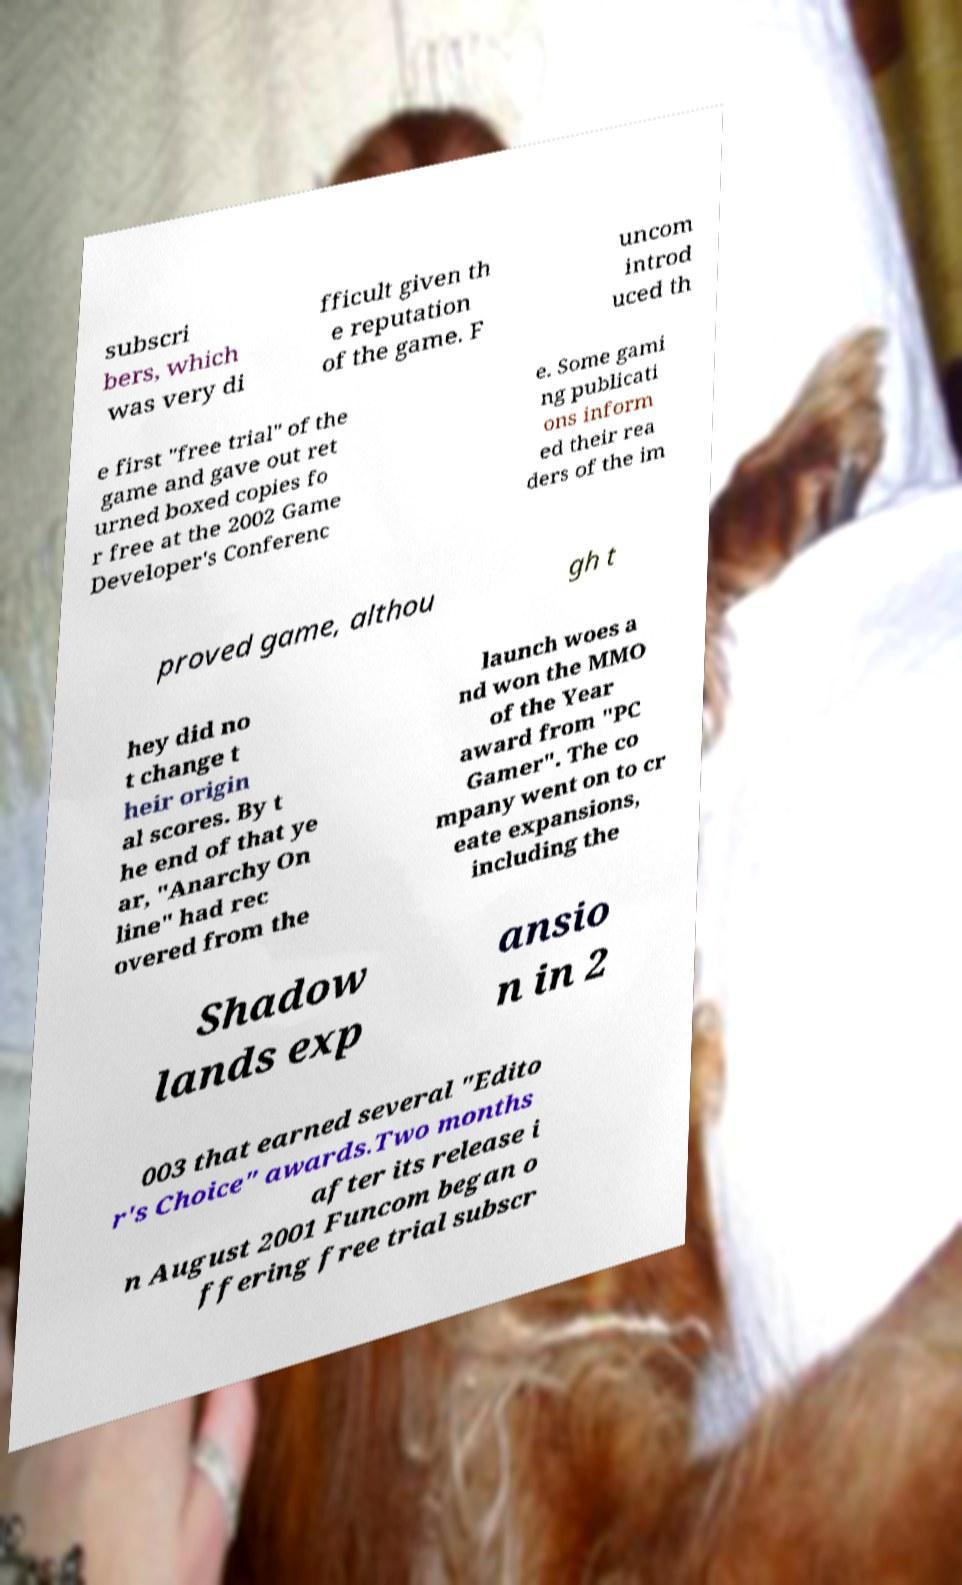What messages or text are displayed in this image? I need them in a readable, typed format. subscri bers, which was very di fficult given th e reputation of the game. F uncom introd uced th e first "free trial" of the game and gave out ret urned boxed copies fo r free at the 2002 Game Developer's Conferenc e. Some gami ng publicati ons inform ed their rea ders of the im proved game, althou gh t hey did no t change t heir origin al scores. By t he end of that ye ar, "Anarchy On line" had rec overed from the launch woes a nd won the MMO of the Year award from "PC Gamer". The co mpany went on to cr eate expansions, including the Shadow lands exp ansio n in 2 003 that earned several "Edito r's Choice" awards.Two months after its release i n August 2001 Funcom began o ffering free trial subscr 